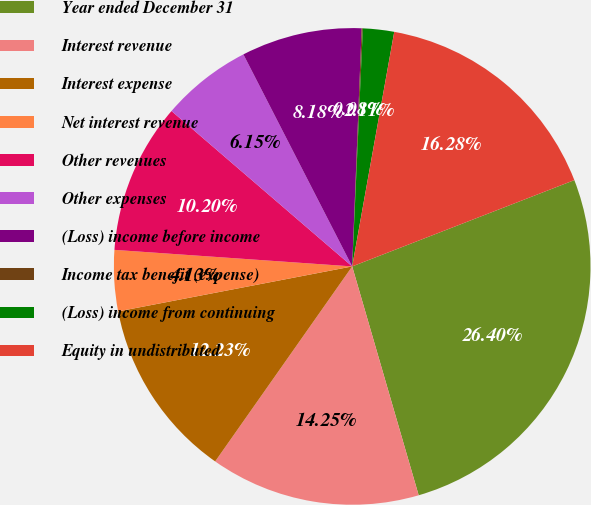Convert chart to OTSL. <chart><loc_0><loc_0><loc_500><loc_500><pie_chart><fcel>Year ended December 31<fcel>Interest revenue<fcel>Interest expense<fcel>Net interest revenue<fcel>Other revenues<fcel>Other expenses<fcel>(Loss) income before income<fcel>Income tax benefit (expense)<fcel>(Loss) income from continuing<fcel>Equity in undistributed<nl><fcel>26.4%<fcel>14.25%<fcel>12.23%<fcel>4.13%<fcel>10.2%<fcel>6.15%<fcel>8.18%<fcel>0.08%<fcel>2.11%<fcel>16.28%<nl></chart> 